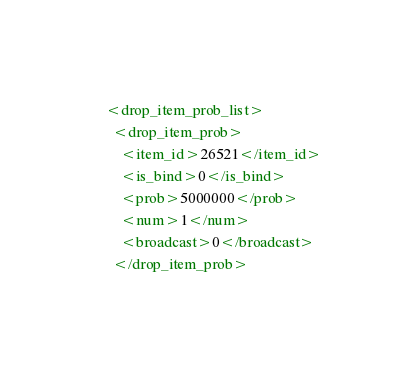<code> <loc_0><loc_0><loc_500><loc_500><_XML_>  <drop_item_prob_list>
    <drop_item_prob>
      <item_id>26521</item_id>
      <is_bind>0</is_bind>
      <prob>5000000</prob>
      <num>1</num>
      <broadcast>0</broadcast>
    </drop_item_prob></code> 